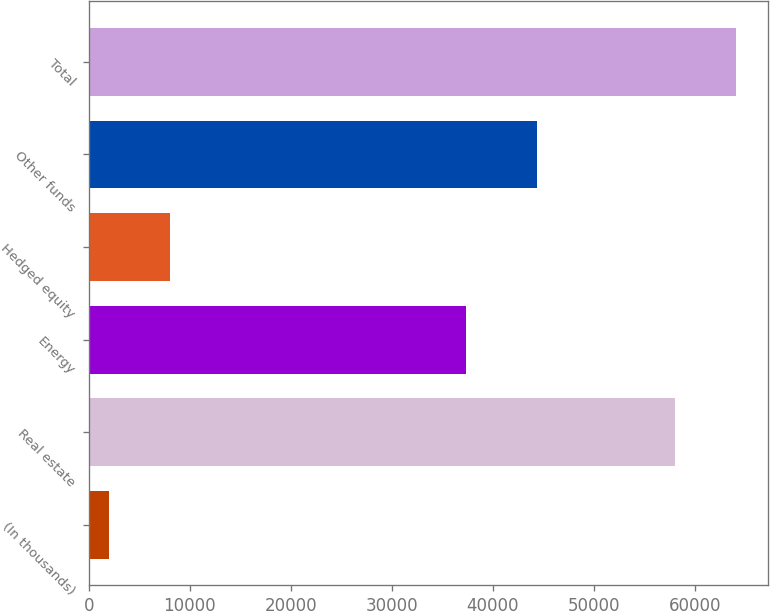Convert chart. <chart><loc_0><loc_0><loc_500><loc_500><bar_chart><fcel>(In thousands)<fcel>Real estate<fcel>Energy<fcel>Hedged equity<fcel>Other funds<fcel>Total<nl><fcel>2015<fcel>58032<fcel>37373<fcel>8036.3<fcel>44331<fcel>64053.3<nl></chart> 